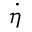Convert formula to latex. <formula><loc_0><loc_0><loc_500><loc_500>\dot { \eta }</formula> 